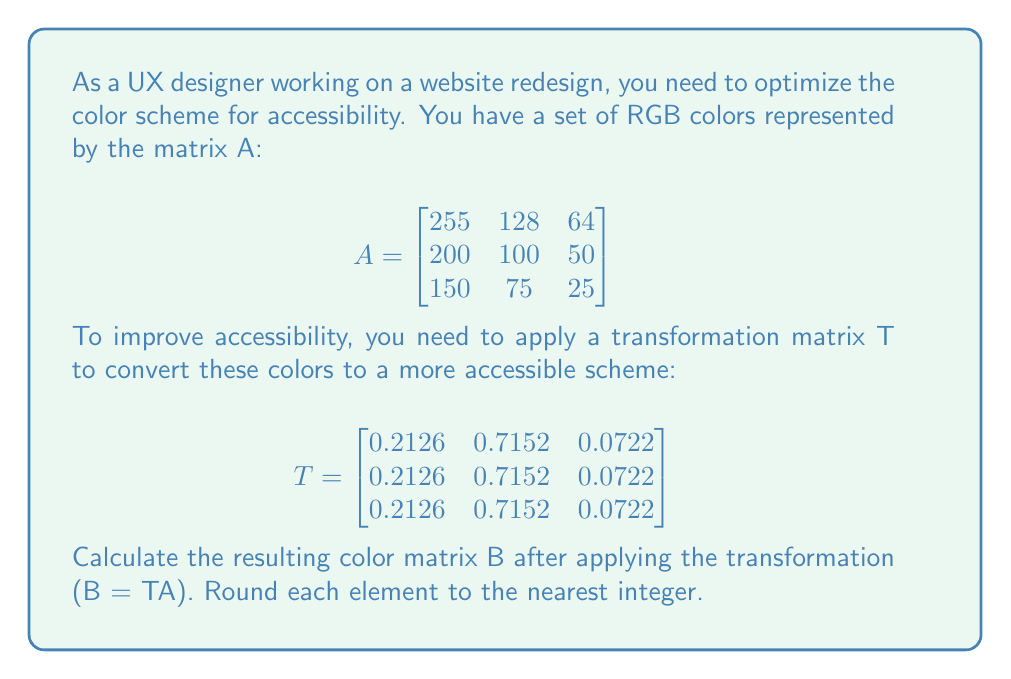Can you solve this math problem? To solve this problem, we need to perform matrix multiplication of T and A. The resulting matrix B will have the same dimensions as A (3x3).

Step 1: Set up the matrix multiplication
$$B = TA = \begin{bmatrix}
0.2126 & 0.7152 & 0.0722 \\
0.2126 & 0.7152 & 0.0722 \\
0.2126 & 0.7152 & 0.0722
\end{bmatrix} \times \begin{bmatrix}
255 & 128 & 64 \\
200 & 100 & 50 \\
150 & 75 & 25
\end{bmatrix}$$

Step 2: Calculate each element of the resulting matrix
For B[1,1]:
$$(0.2126 \times 255) + (0.7152 \times 200) + (0.0722 \times 150) = 54.213 + 143.04 + 10.83 = 208.083$$

For B[1,2]:
$$(0.2126 \times 128) + (0.7152 \times 100) + (0.0722 \times 75) = 27.2128 + 71.52 + 5.415 = 104.1478$$

For B[1,3]:
$$(0.2126 \times 64) + (0.7152 \times 50) + (0.0722 \times 25) = 13.6064 + 35.76 + 1.805 = 51.1714$$

Since all rows in T are identical, the results will be the same for all rows in B.

Step 3: Round each element to the nearest integer
B[1,1] ≈ 208
B[1,2] ≈ 104
B[1,3] ≈ 51

Step 4: Construct the final matrix B
$$B = \begin{bmatrix}
208 & 104 & 51 \\
208 & 104 & 51 \\
208 & 104 & 51
\end{bmatrix}$$
Answer: $$\begin{bmatrix}
208 & 104 & 51 \\
208 & 104 & 51 \\
208 & 104 & 51
\end{bmatrix}$$ 